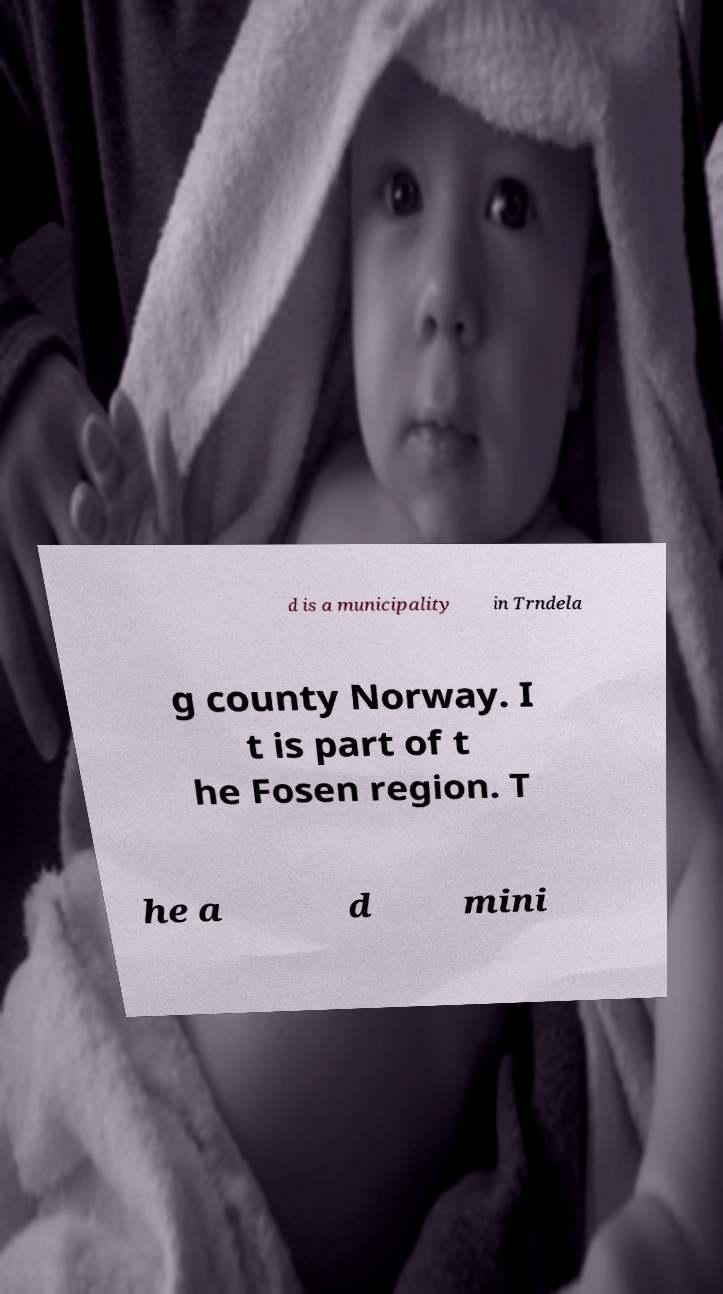Could you extract and type out the text from this image? d is a municipality in Trndela g county Norway. I t is part of t he Fosen region. T he a d mini 